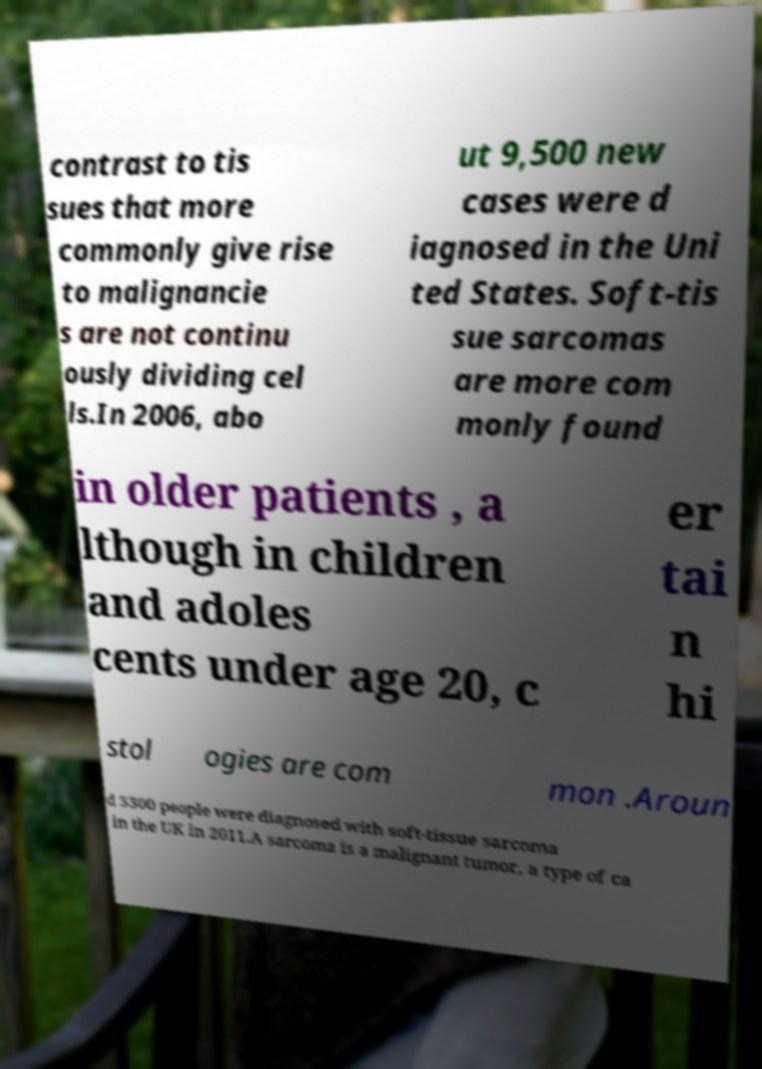Can you accurately transcribe the text from the provided image for me? contrast to tis sues that more commonly give rise to malignancie s are not continu ously dividing cel ls.In 2006, abo ut 9,500 new cases were d iagnosed in the Uni ted States. Soft-tis sue sarcomas are more com monly found in older patients , a lthough in children and adoles cents under age 20, c er tai n hi stol ogies are com mon .Aroun d 3300 people were diagnosed with soft-tissue sarcoma in the UK in 2011.A sarcoma is a malignant tumor, a type of ca 